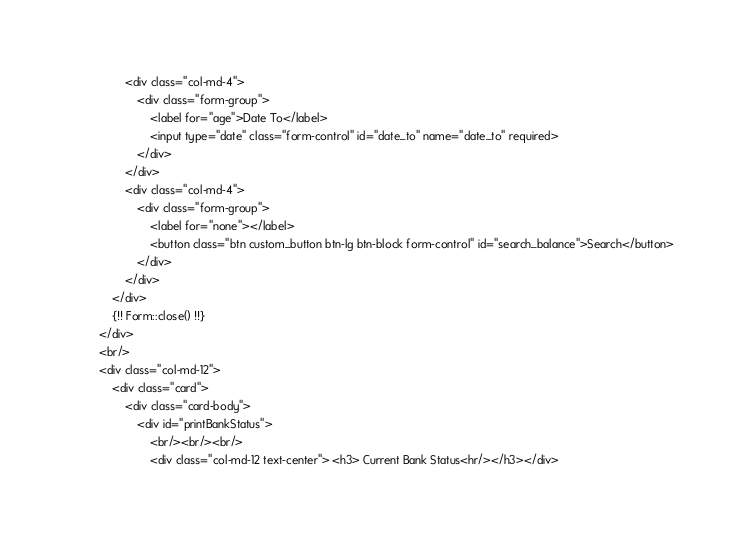<code> <loc_0><loc_0><loc_500><loc_500><_PHP_>                <div class="col-md-4">
                    <div class="form-group">
                        <label for="age">Date To</label>
                        <input type="date" class="form-control" id="date_to" name="date_to" required>
                    </div>
                </div>
                <div class="col-md-4">
                    <div class="form-group">
                        <label for="none"></label>
                        <button class="btn custom_button btn-lg btn-block form-control" id="search_balance">Search</button>
                    </div>
                </div>
            </div>
            {!! Form::close() !!}
        </div>
        <br/>
        <div class="col-md-12">
            <div class="card">
                <div class="card-body">
                    <div id="printBankStatus">
                        <br/><br/><br/>
                        <div class="col-md-12 text-center"> <h3> Current Bank Status<hr/></h3></div></code> 